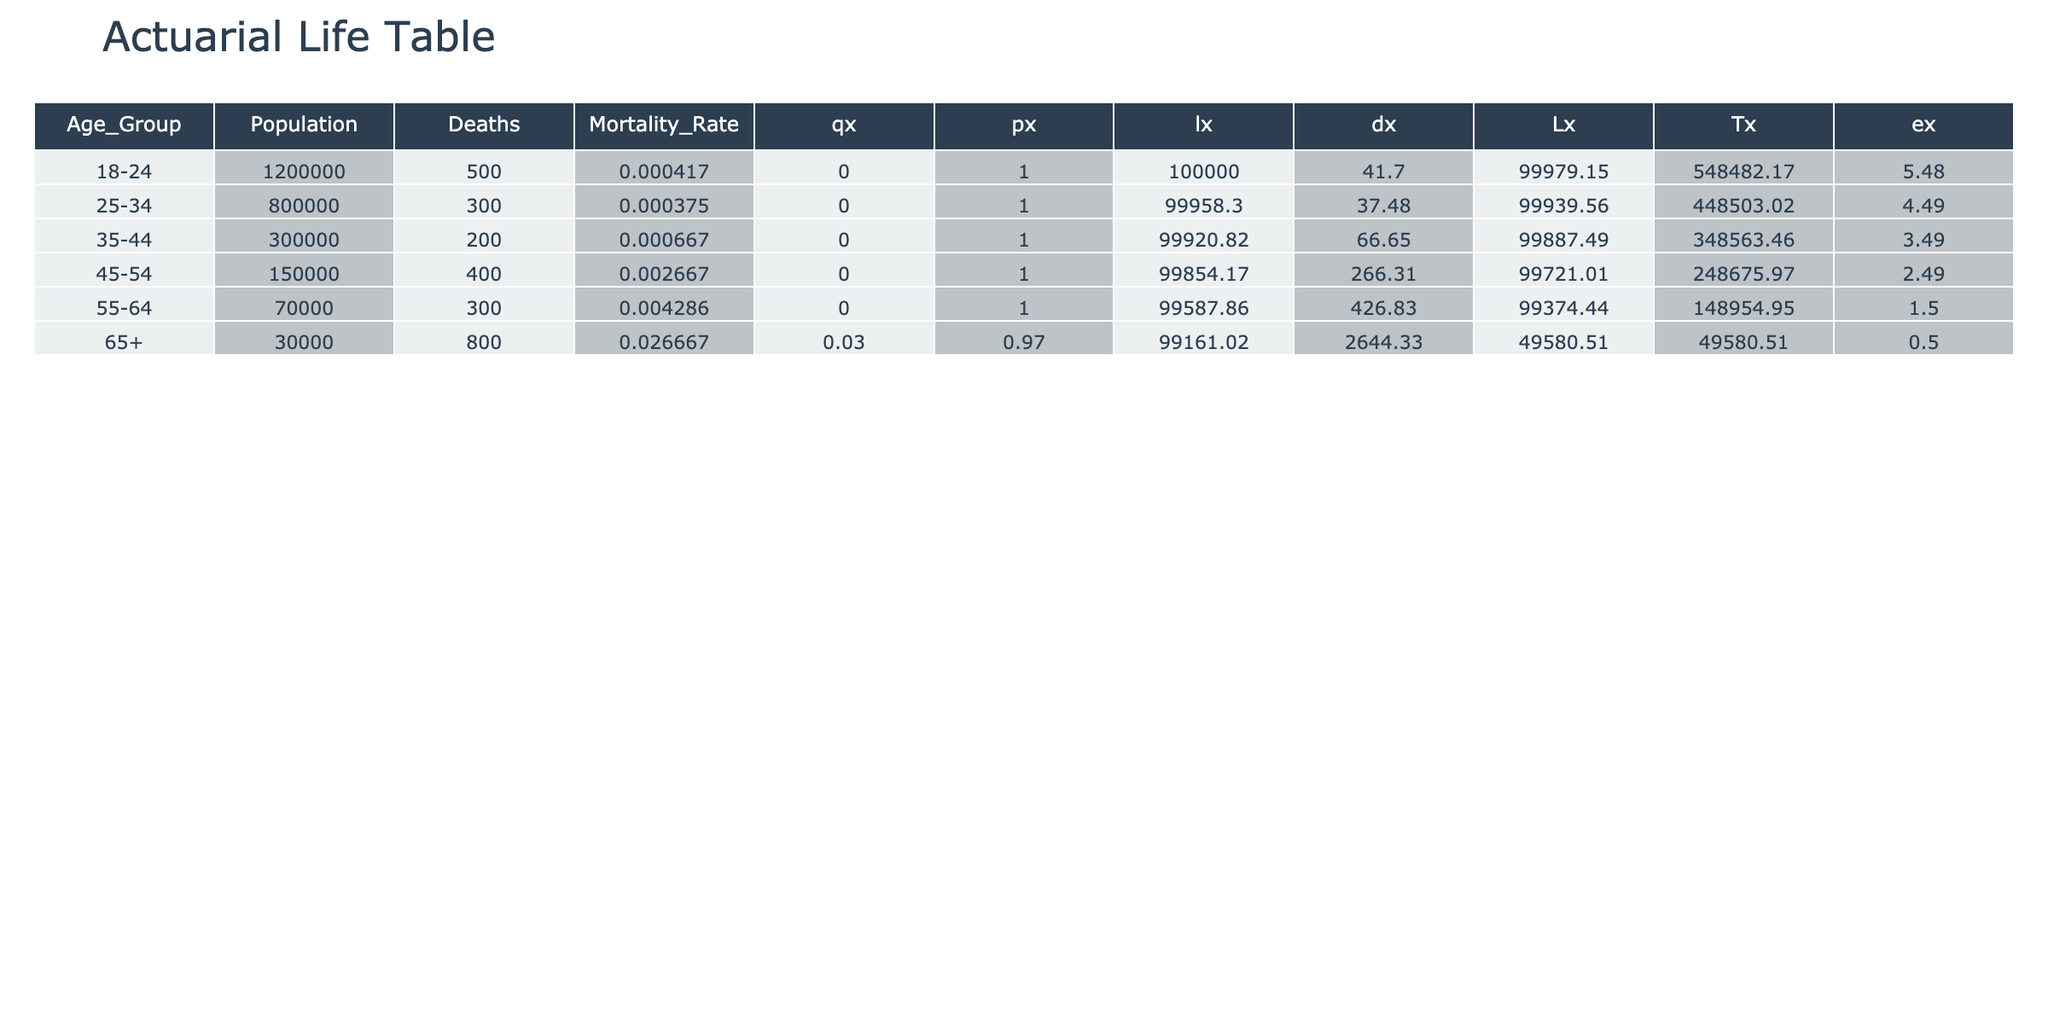What is the mortality rate for the age group 25-34? The mortality rate for the age group 25-34 is directly shown in the table under the Mortality Rate column, which indicates 0.000375.
Answer: 0.000375 Which age group has the highest number of deaths? By comparing the Deaths column across all age groups, the age group 65+ has the highest deaths recorded, with 800.
Answer: 65+ What is the sum of the populations for all age groups? To find the sum, we add all the values in the Population column: 1200000 + 800000 + 300000 + 150000 + 70000 + 30000 = 2210000.
Answer: 2210000 Is the mortality rate for the age group 55-64 higher than that of the age group 45-54? The mortality rate for the age group 55-64 is 0.004286, while for the age group 45-54, it is 0.002667. Since 0.004286 is greater than 0.002667, the statement is true.
Answer: Yes What is the average mortality rate across all age groups? To find the average, we sum up the mortality rates from all age groups: (0.000417 + 0.000375 + 0.000667 + 0.002667 + 0.004286 + 0.026667) and divide by 6 (number of age groups). This gives (0.034079 / 6) = 0.0056798333, rounding to four decimal places gives 0.0057.
Answer: 0.0057 In which age group does the number of deaths exceed the total population of 30000? The age groups 18-24, 25-34, 35-44, 45-54, and 55-64 all have more deaths than the 30000 population threshold, specifically, they have 500, 300, 200, 400, and 300 deaths respectively. The only age group that does not exceed this population total is 65+, which has 800 deaths, but all others do.
Answer: Yes, age groups 18-24, 25-34, 35-44, 45-54, 55-64 exceed 30000 deaths What is the probability of dying for someone aged 45-54? The probability of dying is given by the Mortality Rate column for the age group 45-54, which is 0.002667. This means that the probability of dying for someone in this age group is 0.002667 or 0.267%.
Answer: 0.002667 What is the difference in the mortality rate between the oldest and the youngest age groups? The mortality rate for the age group 65+ is 0.026667 and for the age group 18-24 it is 0.000417. The difference is calculated by subtracting the younger group's rate from the older group's rate: 0.026667 - 0.000417 = 0.02625.
Answer: 0.02625 